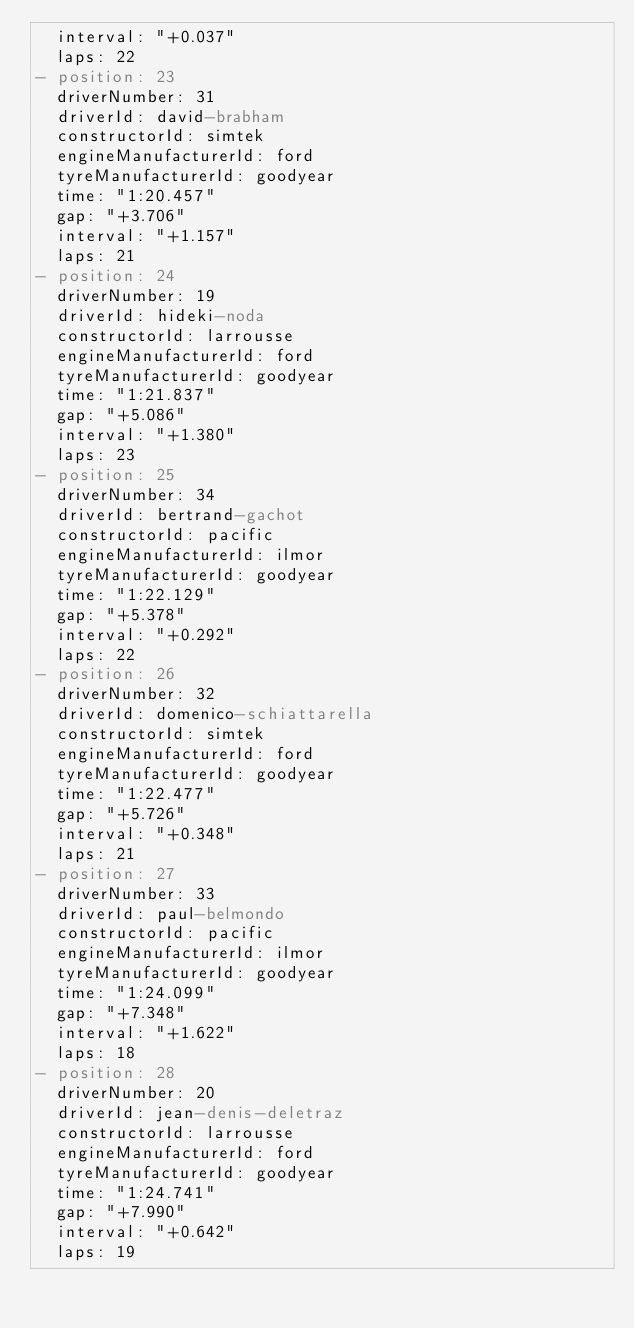Convert code to text. <code><loc_0><loc_0><loc_500><loc_500><_YAML_>  interval: "+0.037"
  laps: 22
- position: 23
  driverNumber: 31
  driverId: david-brabham
  constructorId: simtek
  engineManufacturerId: ford
  tyreManufacturerId: goodyear
  time: "1:20.457"
  gap: "+3.706"
  interval: "+1.157"
  laps: 21
- position: 24
  driverNumber: 19
  driverId: hideki-noda
  constructorId: larrousse
  engineManufacturerId: ford
  tyreManufacturerId: goodyear
  time: "1:21.837"
  gap: "+5.086"
  interval: "+1.380"
  laps: 23
- position: 25
  driverNumber: 34
  driverId: bertrand-gachot
  constructorId: pacific
  engineManufacturerId: ilmor
  tyreManufacturerId: goodyear
  time: "1:22.129"
  gap: "+5.378"
  interval: "+0.292"
  laps: 22
- position: 26
  driverNumber: 32
  driverId: domenico-schiattarella
  constructorId: simtek
  engineManufacturerId: ford
  tyreManufacturerId: goodyear
  time: "1:22.477"
  gap: "+5.726"
  interval: "+0.348"
  laps: 21
- position: 27
  driverNumber: 33
  driverId: paul-belmondo
  constructorId: pacific
  engineManufacturerId: ilmor
  tyreManufacturerId: goodyear
  time: "1:24.099"
  gap: "+7.348"
  interval: "+1.622"
  laps: 18
- position: 28
  driverNumber: 20
  driverId: jean-denis-deletraz
  constructorId: larrousse
  engineManufacturerId: ford
  tyreManufacturerId: goodyear
  time: "1:24.741"
  gap: "+7.990"
  interval: "+0.642"
  laps: 19
</code> 